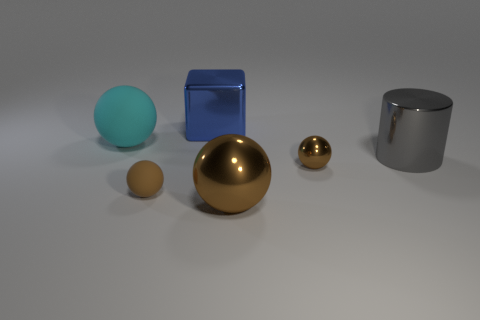What color is the other matte thing that is the same shape as the cyan object?
Ensure brevity in your answer.  Brown. What number of cylinders are brown metallic things or cyan rubber objects?
Provide a succinct answer. 0. What is the color of the large cylinder that is made of the same material as the blue thing?
Offer a terse response. Gray. Is the block made of the same material as the large ball that is in front of the large cylinder?
Keep it short and to the point. Yes. What number of things are gray cylinders or tiny blue things?
Keep it short and to the point. 1. What is the material of the other tiny ball that is the same color as the small shiny ball?
Keep it short and to the point. Rubber. Is there a tiny thing that has the same shape as the large cyan matte object?
Give a very brief answer. Yes. What number of large cyan rubber spheres are to the right of the large gray shiny object?
Your response must be concise. 0. There is a tiny brown ball behind the brown sphere on the left side of the cube; what is its material?
Your answer should be compact. Metal. There is a cylinder that is the same size as the cyan rubber thing; what is its material?
Ensure brevity in your answer.  Metal. 